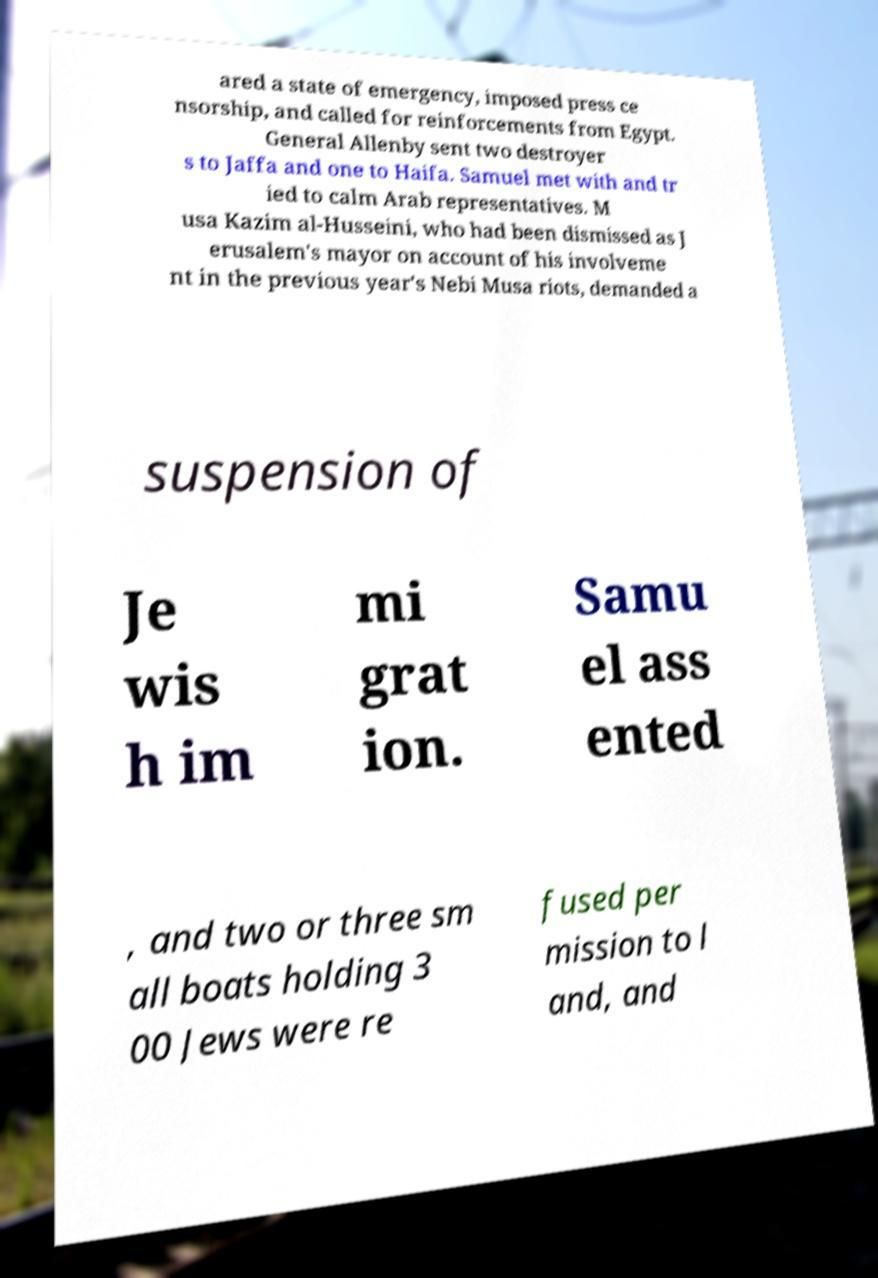I need the written content from this picture converted into text. Can you do that? ared a state of emergency, imposed press ce nsorship, and called for reinforcements from Egypt. General Allenby sent two destroyer s to Jaffa and one to Haifa. Samuel met with and tr ied to calm Arab representatives. M usa Kazim al-Husseini, who had been dismissed as J erusalem's mayor on account of his involveme nt in the previous year's Nebi Musa riots, demanded a suspension of Je wis h im mi grat ion. Samu el ass ented , and two or three sm all boats holding 3 00 Jews were re fused per mission to l and, and 